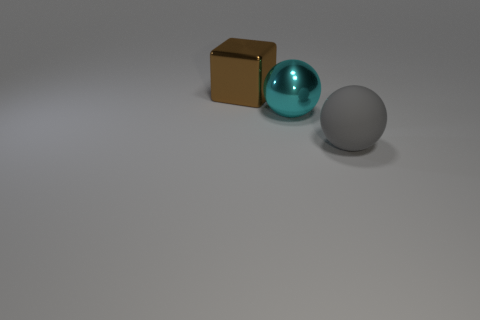Add 2 large brown metal things. How many objects exist? 5 Subtract all spheres. How many objects are left? 1 Add 3 large blocks. How many large blocks are left? 4 Add 2 balls. How many balls exist? 4 Subtract 0 yellow cubes. How many objects are left? 3 Subtract all big brown shiny objects. Subtract all big brown metallic cylinders. How many objects are left? 2 